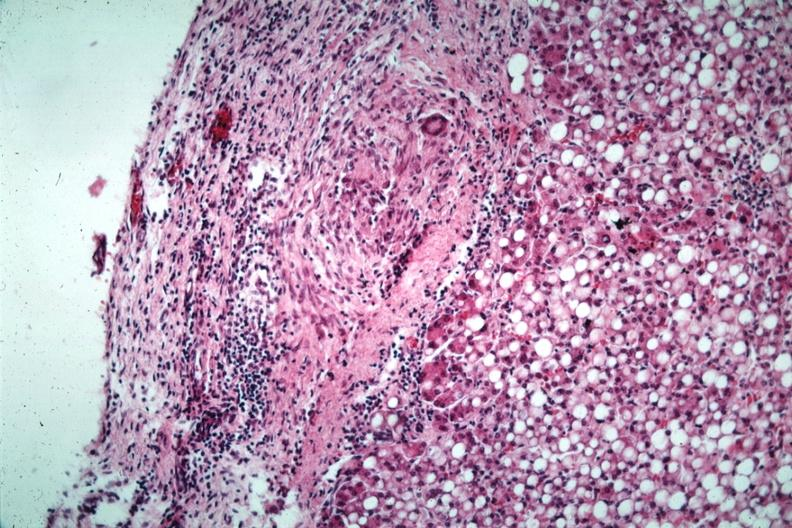s opened muscle present?
Answer the question using a single word or phrase. No 